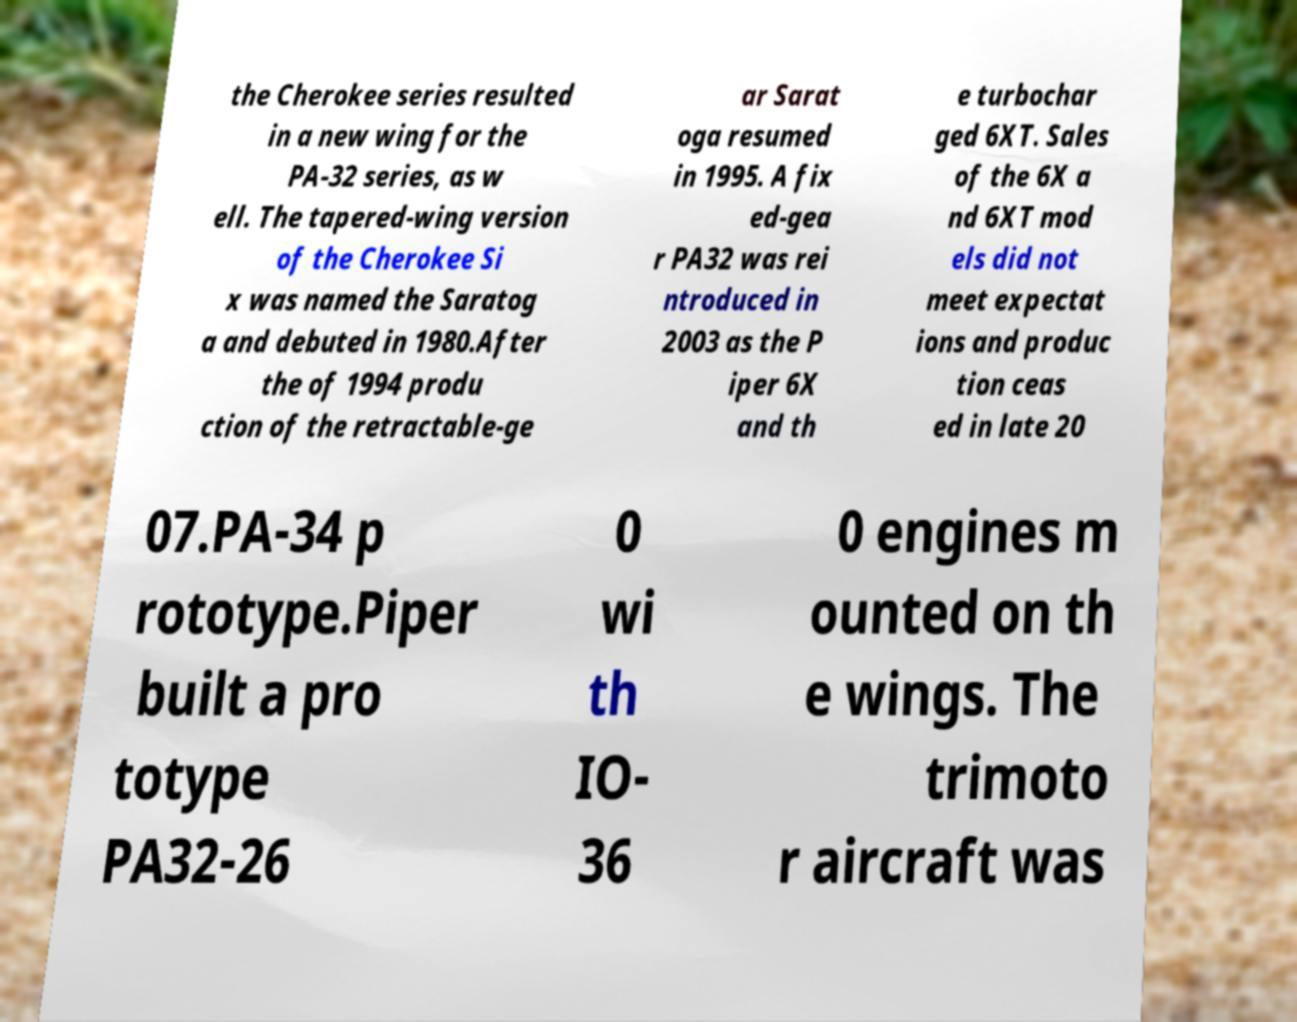Please read and relay the text visible in this image. What does it say? the Cherokee series resulted in a new wing for the PA-32 series, as w ell. The tapered-wing version of the Cherokee Si x was named the Saratog a and debuted in 1980.After the of 1994 produ ction of the retractable-ge ar Sarat oga resumed in 1995. A fix ed-gea r PA32 was rei ntroduced in 2003 as the P iper 6X and th e turbochar ged 6XT. Sales of the 6X a nd 6XT mod els did not meet expectat ions and produc tion ceas ed in late 20 07.PA-34 p rototype.Piper built a pro totype PA32-26 0 wi th IO- 36 0 engines m ounted on th e wings. The trimoto r aircraft was 